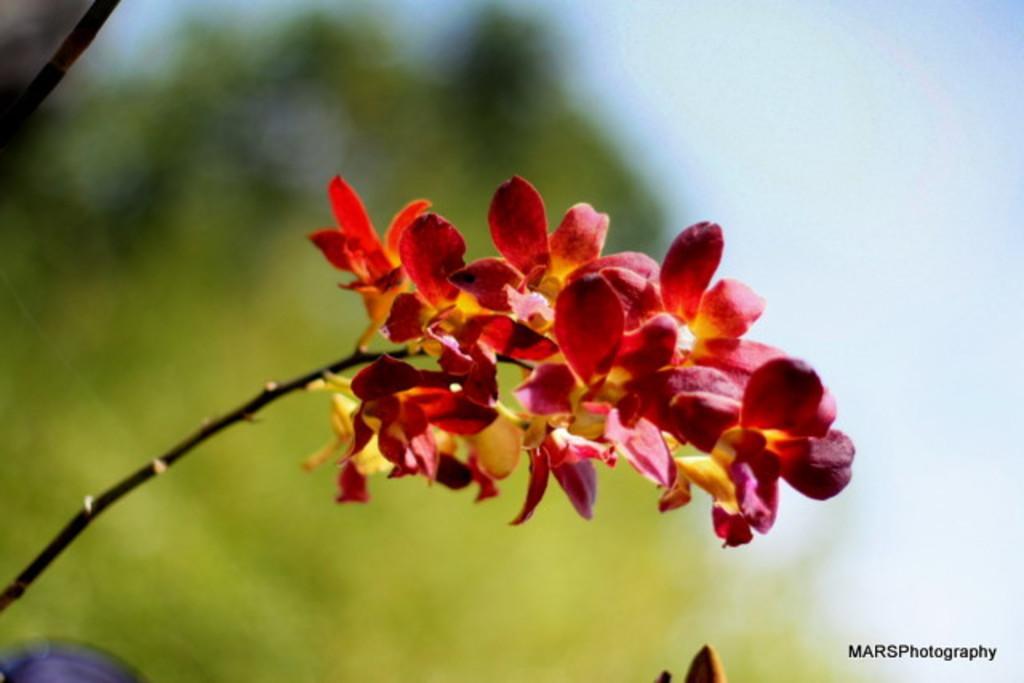How would you summarize this image in a sentence or two? In this image there are flowers, in the background it is blurred, in the bottom right there is text. 